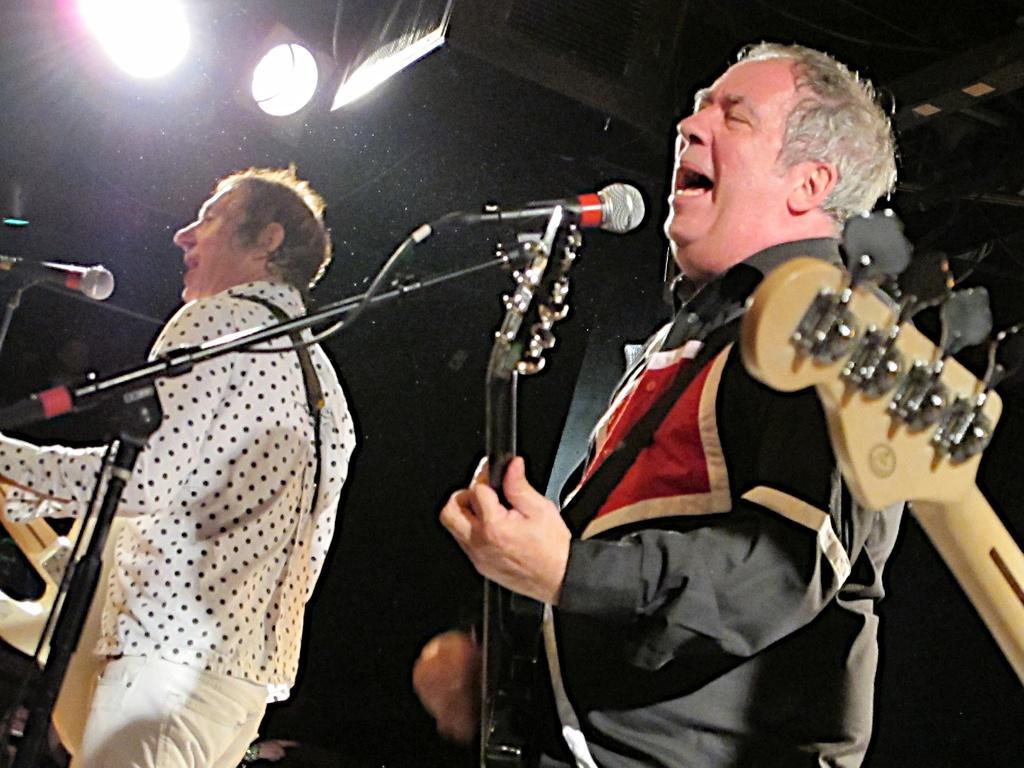Please provide a concise description of this image. This image two persons standing and playing a guitar are holding them in their hands. Person at the right side is singing is wearing a black shirt, left side is wearing white shirt and white pant. There are two mikes before them. At the top left corner there are lights. At the right side there is a guitar. 